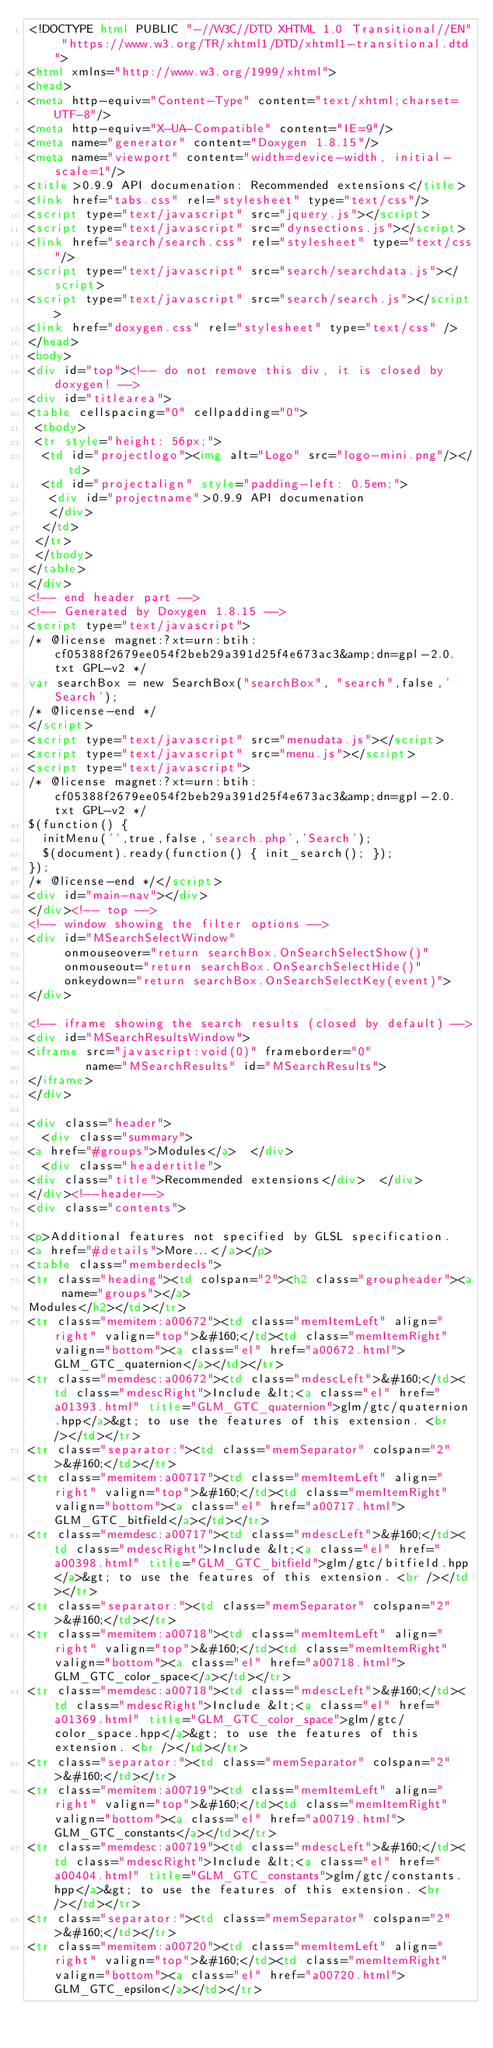<code> <loc_0><loc_0><loc_500><loc_500><_HTML_><!DOCTYPE html PUBLIC "-//W3C//DTD XHTML 1.0 Transitional//EN" "https://www.w3.org/TR/xhtml1/DTD/xhtml1-transitional.dtd">
<html xmlns="http://www.w3.org/1999/xhtml">
<head>
<meta http-equiv="Content-Type" content="text/xhtml;charset=UTF-8"/>
<meta http-equiv="X-UA-Compatible" content="IE=9"/>
<meta name="generator" content="Doxygen 1.8.15"/>
<meta name="viewport" content="width=device-width, initial-scale=1"/>
<title>0.9.9 API documenation: Recommended extensions</title>
<link href="tabs.css" rel="stylesheet" type="text/css"/>
<script type="text/javascript" src="jquery.js"></script>
<script type="text/javascript" src="dynsections.js"></script>
<link href="search/search.css" rel="stylesheet" type="text/css"/>
<script type="text/javascript" src="search/searchdata.js"></script>
<script type="text/javascript" src="search/search.js"></script>
<link href="doxygen.css" rel="stylesheet" type="text/css" />
</head>
<body>
<div id="top"><!-- do not remove this div, it is closed by doxygen! -->
<div id="titlearea">
<table cellspacing="0" cellpadding="0">
 <tbody>
 <tr style="height: 56px;">
  <td id="projectlogo"><img alt="Logo" src="logo-mini.png"/></td>
  <td id="projectalign" style="padding-left: 0.5em;">
   <div id="projectname">0.9.9 API documenation
   </div>
  </td>
 </tr>
 </tbody>
</table>
</div>
<!-- end header part -->
<!-- Generated by Doxygen 1.8.15 -->
<script type="text/javascript">
/* @license magnet:?xt=urn:btih:cf05388f2679ee054f2beb29a391d25f4e673ac3&amp;dn=gpl-2.0.txt GPL-v2 */
var searchBox = new SearchBox("searchBox", "search",false,'Search');
/* @license-end */
</script>
<script type="text/javascript" src="menudata.js"></script>
<script type="text/javascript" src="menu.js"></script>
<script type="text/javascript">
/* @license magnet:?xt=urn:btih:cf05388f2679ee054f2beb29a391d25f4e673ac3&amp;dn=gpl-2.0.txt GPL-v2 */
$(function() {
  initMenu('',true,false,'search.php','Search');
  $(document).ready(function() { init_search(); });
});
/* @license-end */</script>
<div id="main-nav"></div>
</div><!-- top -->
<!-- window showing the filter options -->
<div id="MSearchSelectWindow"
     onmouseover="return searchBox.OnSearchSelectShow()"
     onmouseout="return searchBox.OnSearchSelectHide()"
     onkeydown="return searchBox.OnSearchSelectKey(event)">
</div>

<!-- iframe showing the search results (closed by default) -->
<div id="MSearchResultsWindow">
<iframe src="javascript:void(0)" frameborder="0" 
        name="MSearchResults" id="MSearchResults">
</iframe>
</div>

<div class="header">
  <div class="summary">
<a href="#groups">Modules</a>  </div>
  <div class="headertitle">
<div class="title">Recommended extensions</div>  </div>
</div><!--header-->
<div class="contents">

<p>Additional features not specified by GLSL specification.  
<a href="#details">More...</a></p>
<table class="memberdecls">
<tr class="heading"><td colspan="2"><h2 class="groupheader"><a name="groups"></a>
Modules</h2></td></tr>
<tr class="memitem:a00672"><td class="memItemLeft" align="right" valign="top">&#160;</td><td class="memItemRight" valign="bottom"><a class="el" href="a00672.html">GLM_GTC_quaternion</a></td></tr>
<tr class="memdesc:a00672"><td class="mdescLeft">&#160;</td><td class="mdescRight">Include &lt;<a class="el" href="a01393.html" title="GLM_GTC_quaternion">glm/gtc/quaternion.hpp</a>&gt; to use the features of this extension. <br /></td></tr>
<tr class="separator:"><td class="memSeparator" colspan="2">&#160;</td></tr>
<tr class="memitem:a00717"><td class="memItemLeft" align="right" valign="top">&#160;</td><td class="memItemRight" valign="bottom"><a class="el" href="a00717.html">GLM_GTC_bitfield</a></td></tr>
<tr class="memdesc:a00717"><td class="mdescLeft">&#160;</td><td class="mdescRight">Include &lt;<a class="el" href="a00398.html" title="GLM_GTC_bitfield">glm/gtc/bitfield.hpp</a>&gt; to use the features of this extension. <br /></td></tr>
<tr class="separator:"><td class="memSeparator" colspan="2">&#160;</td></tr>
<tr class="memitem:a00718"><td class="memItemLeft" align="right" valign="top">&#160;</td><td class="memItemRight" valign="bottom"><a class="el" href="a00718.html">GLM_GTC_color_space</a></td></tr>
<tr class="memdesc:a00718"><td class="mdescLeft">&#160;</td><td class="mdescRight">Include &lt;<a class="el" href="a01369.html" title="GLM_GTC_color_space">glm/gtc/color_space.hpp</a>&gt; to use the features of this extension. <br /></td></tr>
<tr class="separator:"><td class="memSeparator" colspan="2">&#160;</td></tr>
<tr class="memitem:a00719"><td class="memItemLeft" align="right" valign="top">&#160;</td><td class="memItemRight" valign="bottom"><a class="el" href="a00719.html">GLM_GTC_constants</a></td></tr>
<tr class="memdesc:a00719"><td class="mdescLeft">&#160;</td><td class="mdescRight">Include &lt;<a class="el" href="a00404.html" title="GLM_GTC_constants">glm/gtc/constants.hpp</a>&gt; to use the features of this extension. <br /></td></tr>
<tr class="separator:"><td class="memSeparator" colspan="2">&#160;</td></tr>
<tr class="memitem:a00720"><td class="memItemLeft" align="right" valign="top">&#160;</td><td class="memItemRight" valign="bottom"><a class="el" href="a00720.html">GLM_GTC_epsilon</a></td></tr></code> 